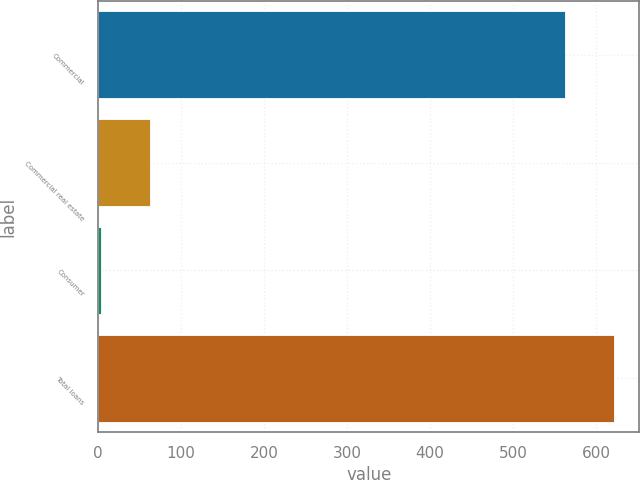Convert chart to OTSL. <chart><loc_0><loc_0><loc_500><loc_500><bar_chart><fcel>Commercial<fcel>Commercial real estate<fcel>Consumer<fcel>Total loans<nl><fcel>563<fcel>62.1<fcel>4<fcel>621.1<nl></chart> 